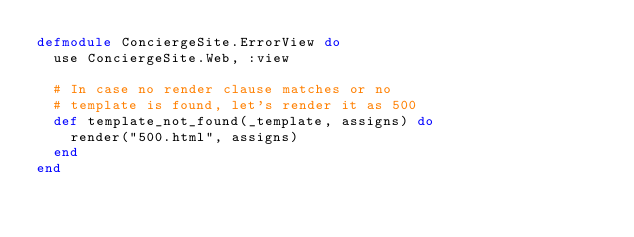<code> <loc_0><loc_0><loc_500><loc_500><_Elixir_>defmodule ConciergeSite.ErrorView do
  use ConciergeSite.Web, :view

  # In case no render clause matches or no
  # template is found, let's render it as 500
  def template_not_found(_template, assigns) do
    render("500.html", assigns)
  end
end
</code> 